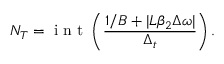<formula> <loc_0><loc_0><loc_500><loc_500>N _ { T } = i n t \left ( \frac { 1 / B + | L \beta _ { 2 } \Delta \omega | } { \Delta _ { t } } \right ) .</formula> 